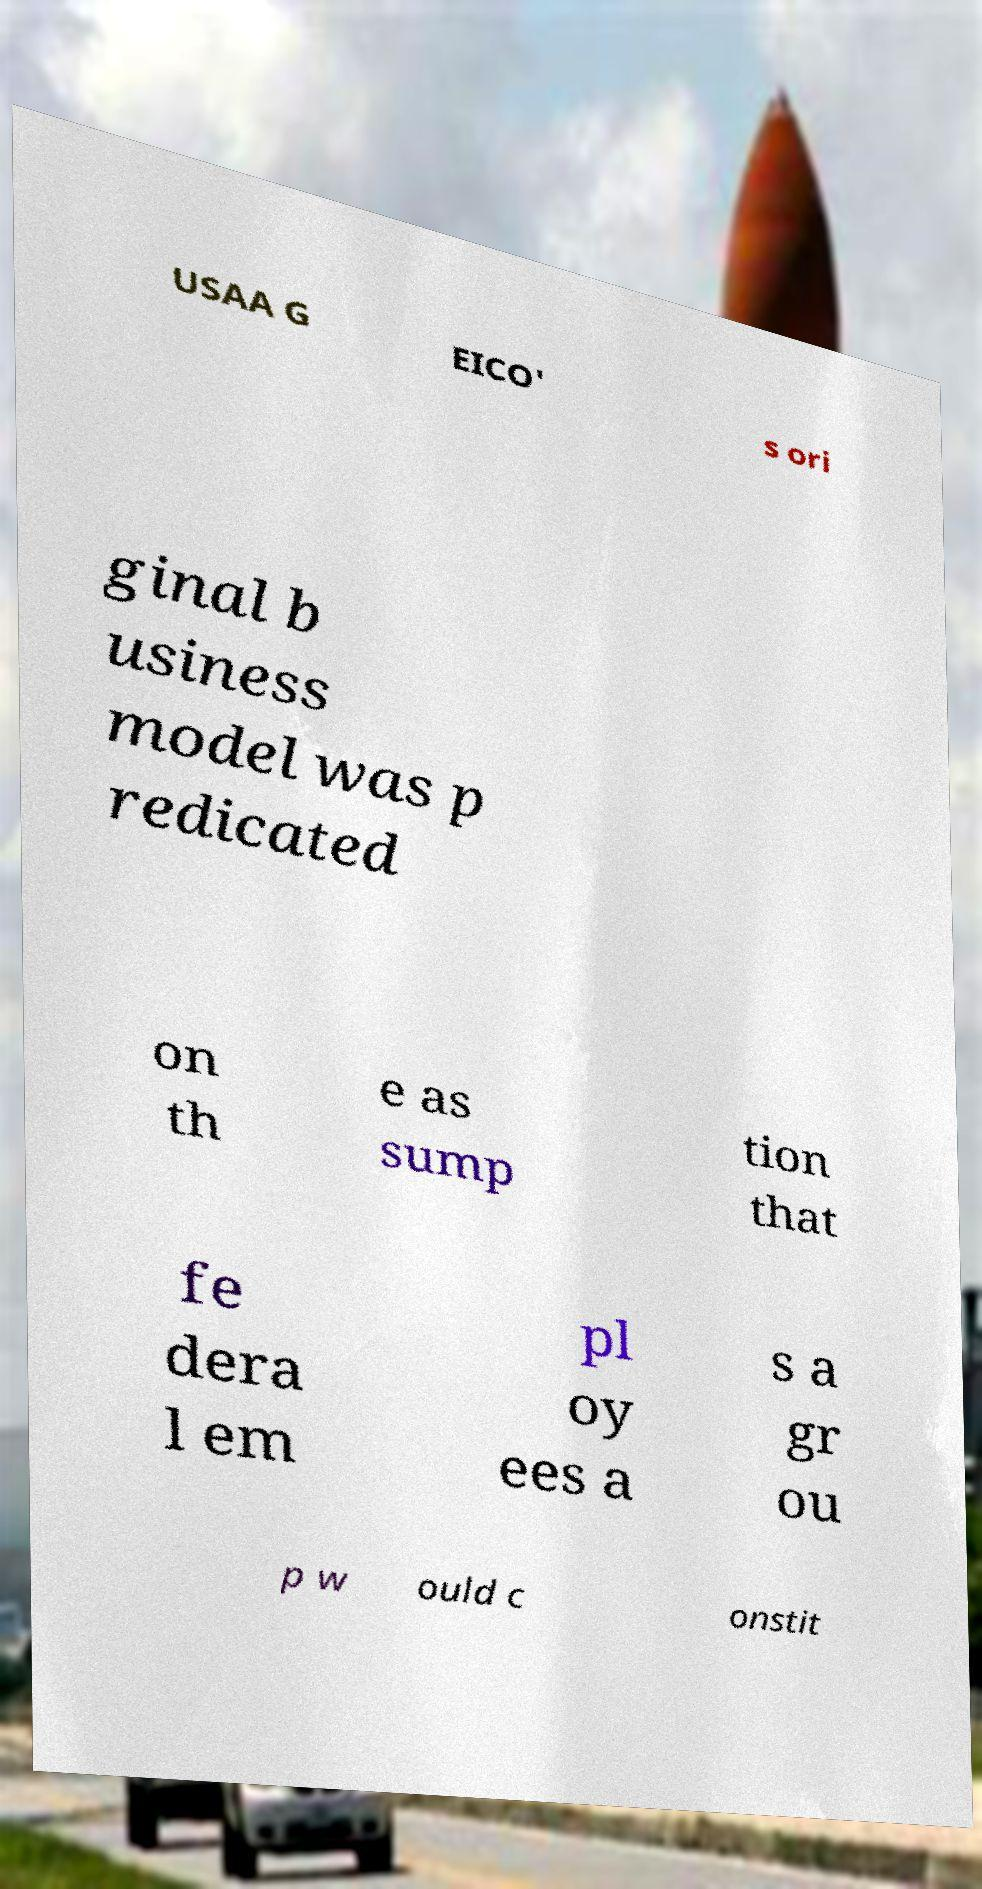Could you assist in decoding the text presented in this image and type it out clearly? USAA G EICO' s ori ginal b usiness model was p redicated on th e as sump tion that fe dera l em pl oy ees a s a gr ou p w ould c onstit 